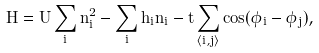Convert formula to latex. <formula><loc_0><loc_0><loc_500><loc_500>\hat { H } = U \sum _ { i } \hat { n } _ { i } ^ { 2 } - \sum _ { i } h _ { i } \hat { n } _ { i } - t \sum _ { \langle i , j \rangle } \cos ( \hat { \phi } _ { i } - \hat { \phi } _ { j } ) ,</formula> 